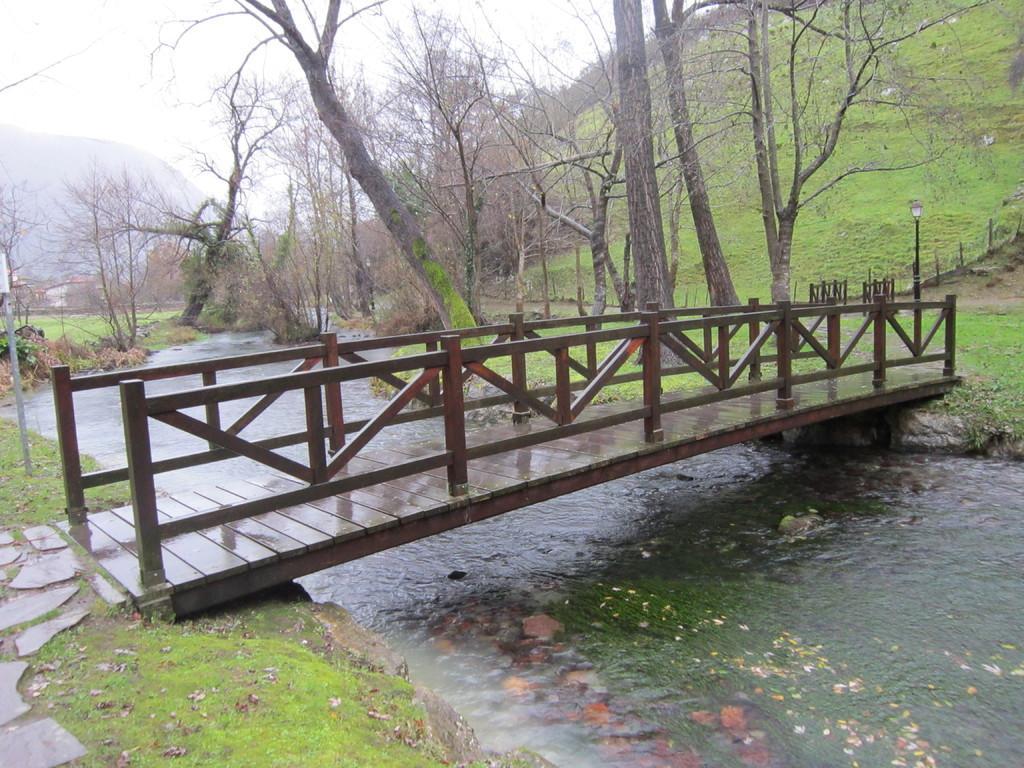Can you describe this image briefly? In the center of the image we can see a bridge. In the background there are trees, hills and sky. At the bottom there is water and we can see grass. On the right there is a pole. 